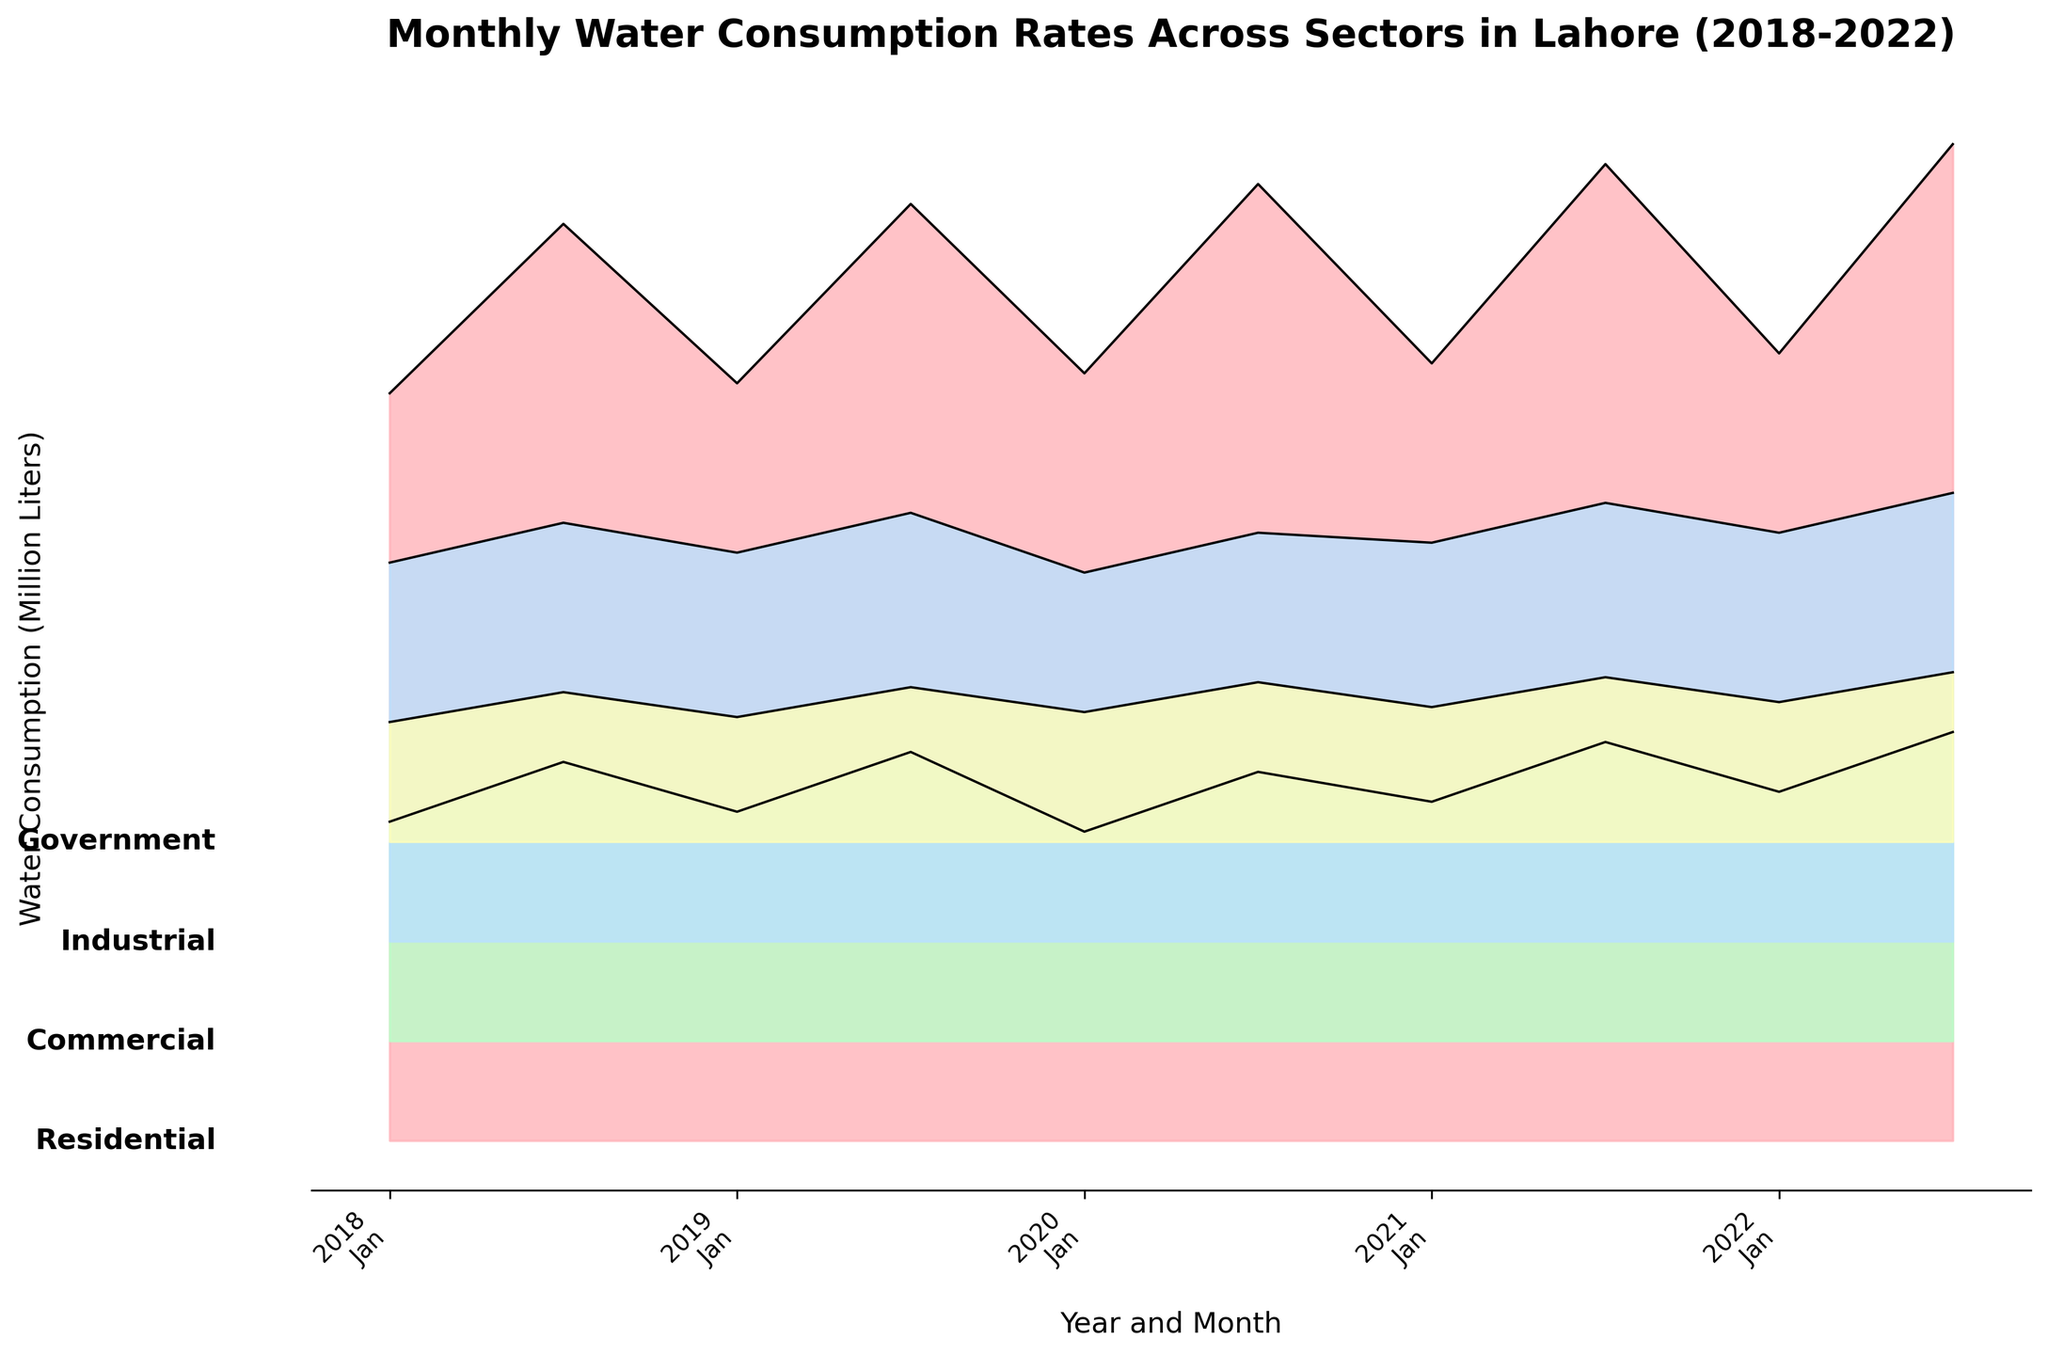Which sector had the highest water consumption in January 2020? To find the sector with the highest water consumption in January 2020, look at the consumption values at the January 2020 point for each sector. The Residential sector has the highest point.
Answer: Residential What is the overall trend of water consumption in the Residential sector from 2018 to 2022? Examine the peaks of the Residential sector layer from 2018 to 2022. Notice that the peaks gradually increase over the years.
Answer: Increasing Which sector showed the least variability in water consumption between January and July each year? Check the difference in the heights of the January and July consumption points for each sector. The Government sector shows the smallest gaps, indicating the least variability.
Answer: Government How does commercial water consumption in July 2021 compare to that in July 2018? Identify the consumption points for Commercial in July 2021 and July 2018. July 2021 is higher than July 2018.
Answer: Higher What is the pattern observed in Industrial sector consumption from January to July each year? Observe the connection between January and July for each year in the Industrial sector. The pattern shows an increase from January to July consistently each year.
Answer: Increase How much did the water consumption in the Government sector increase from July 2018 to July 2022? Look at the July points for 2018 and 2022 in the Government sector and calculate the difference. 1700 (2022) - 1500 (2018) = 200 million liters.
Answer: 200 million liters Which year had the highest water consumption for the Residential sector in July? Look at the peaks for July in the Residential sector, and identify the highest one. July 2022 has the highest peak.
Answer: 2022 What general observation can you make about the pattern of water consumption in July for all sectors from 2018 to 2022? Examine the July data points for all sectors from 2018 to 2022; consumption generally increases over the years with the Residential sector showing the most significant increase.
Answer: Increase Compare the average water consumption in the Industrial sector for January months across all years. Sum the consumption values for January in the Industrial sector and divide by the number of years. (3800 + 3900 + 3700 + 4000 + 4100)/5 = 3900 million liters.
Answer: 3900 million liters 